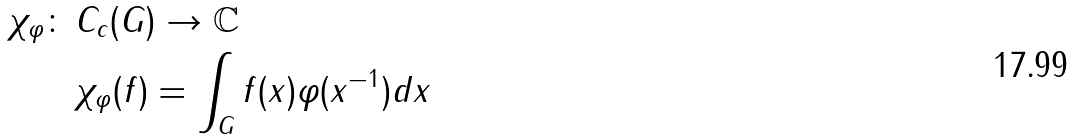Convert formula to latex. <formula><loc_0><loc_0><loc_500><loc_500>\chi _ { \varphi } \colon \, & C _ { c } ( G ) \rightarrow \mathbb { C } \\ & \chi _ { \varphi } ( f ) = \int _ { G } f ( x ) \varphi ( x ^ { - 1 } ) d x</formula> 